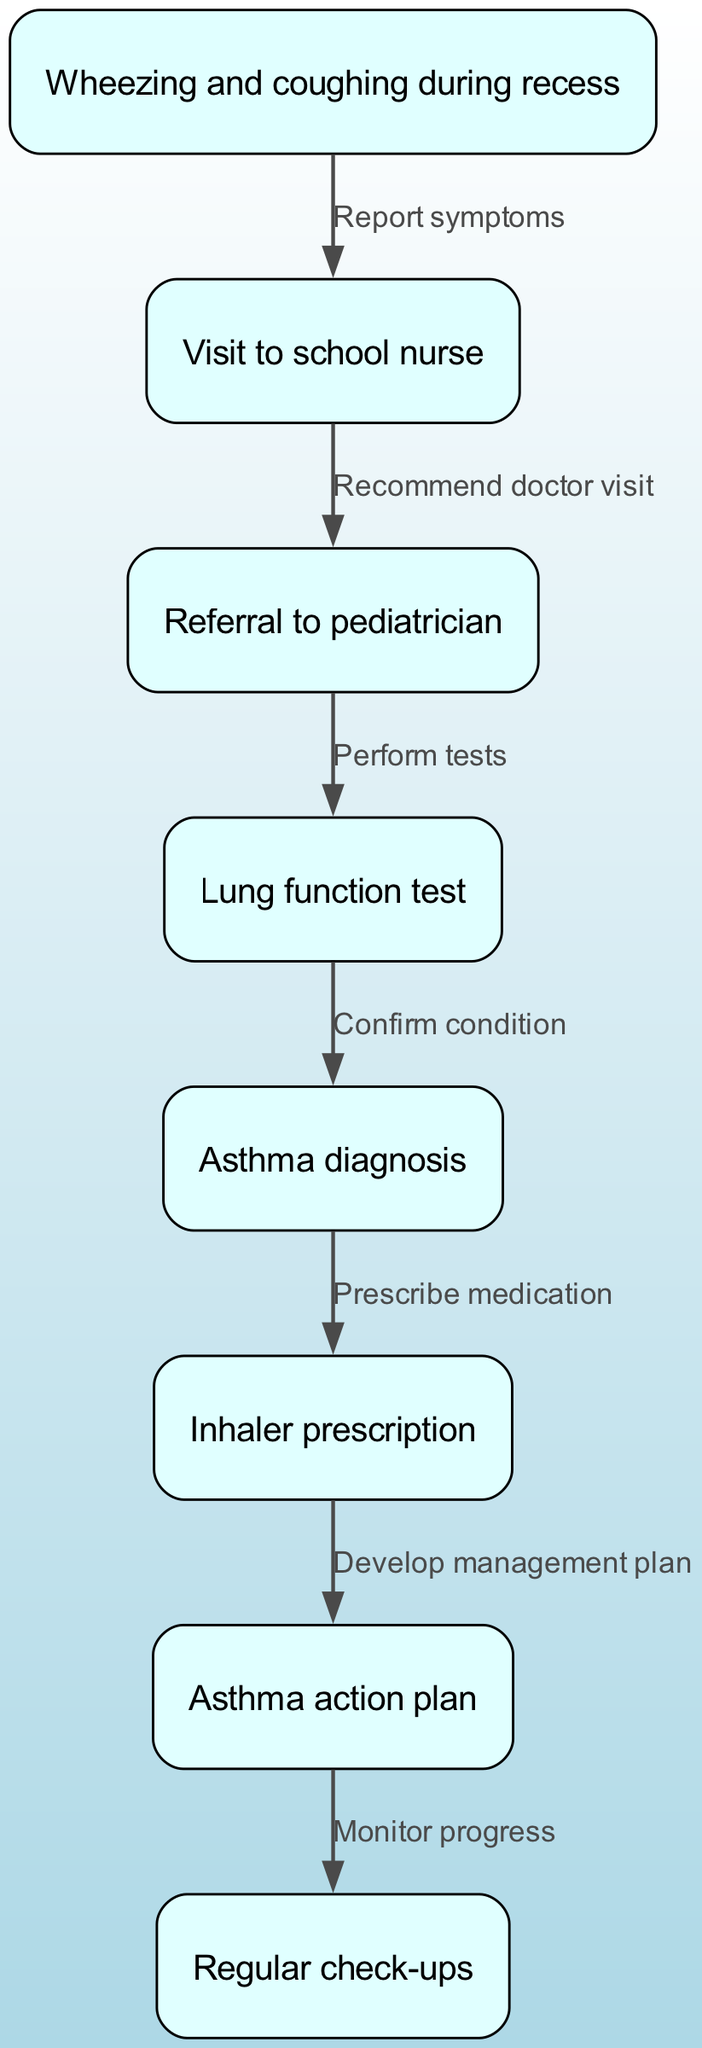What is the first symptom noted in the pathway? The first symptom listed in the nodes is "Wheezing and coughing during recess," marking the starting point of the pathway.
Answer: Wheezing and coughing during recess How many nodes are there in the diagram? By counting the nodes provided in the data, there are a total of eight distinct steps or stages in the treatment pathway.
Answer: 8 What action is recommended after visiting the school nurse? The flow from "Visit to school nurse" leads to "Referral to pediatrician," indicating that the next step is a recommendation for further medical consultation.
Answer: Referral to pediatrician What is prescribed after an asthma diagnosis? According to the progression from "Asthma diagnosis," the next step is to "Inhaler prescription," showing that inhalers are part of the treatment plan after diagnosis.
Answer: Inhaler prescription What is the purpose of the asthma action plan? After the inhaler prescription, the pathway includes "Asthma action plan," which helps to guide management and actions in case of worsening symptoms or attacks.
Answer: Develop management plan How many edges connect the nodes? By examining the edges listed in the data, there are a total of seven connections that illustrate the progression through the pathway.
Answer: 7 What step involves performing tests? The node "Lung function test" directly follows the referral to a pediatrician, showing that this is the specific step where tests are executed.
Answer: Lung function test What is the last step in the childhood asthma treatment pathway? The final node in the diagram is "Regular check-ups," indicating that ongoing monitoring is the last step in this clinical pathway.
Answer: Regular check-ups What does the node indicate after prescribing an inhaler? Following the prescription of the inhaler, the diagram outlines the creation of an "Asthma action plan," which is crucial for managing the child's asthma.
Answer: Asthma action plan 